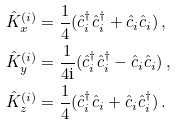<formula> <loc_0><loc_0><loc_500><loc_500>\hat { K } _ { x } ^ { ( i ) } & = \frac { 1 } { 4 } ( \hat { c } _ { i } ^ { \dagger } \hat { c } _ { i } ^ { \dagger } + \hat { c } _ { i } \hat { c } _ { i } ) \, , \\ \hat { K } _ { y } ^ { ( i ) } & = \frac { 1 } { 4 \text {i} } ( \hat { c } _ { i } ^ { \dagger } \hat { c } _ { i } ^ { \dagger } - \hat { c } _ { i } \hat { c } _ { i } ) \, , \\ \hat { K } _ { z } ^ { ( i ) } & = \frac { 1 } { 4 } ( \hat { c } _ { i } ^ { \dagger } \hat { c } _ { i } + \hat { c } _ { i } \hat { c } _ { i } ^ { \dagger } ) \, .</formula> 